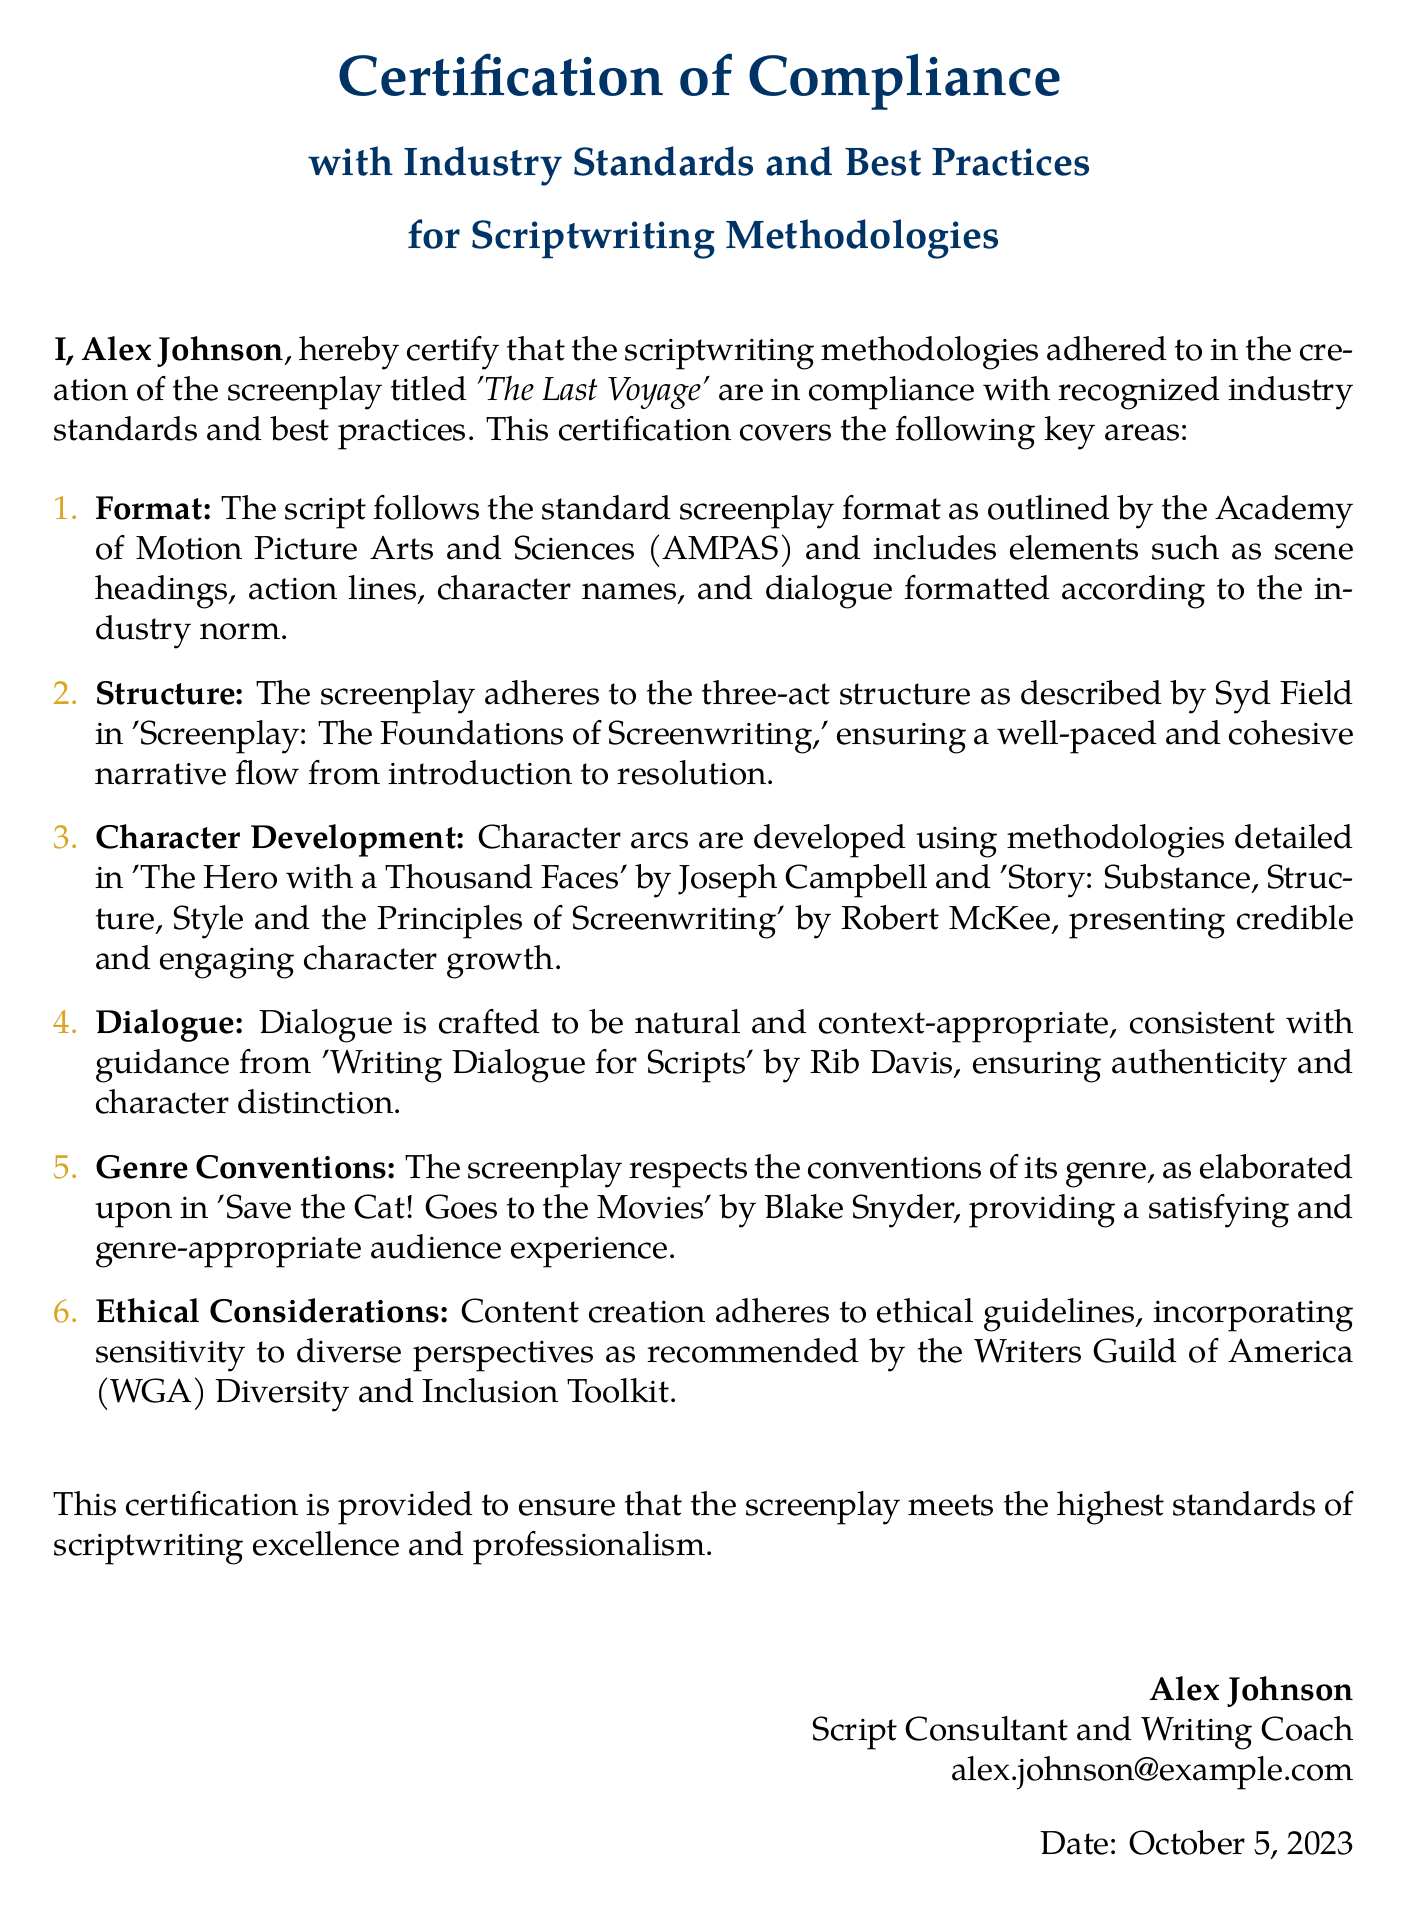What is the name of the author of the declaration? The declaration is signed by Alex Johnson, who is the author.
Answer: Alex Johnson What is the title of the screenplay mentioned in the declaration? The title of the screenplay is explicitly stated as 'The Last Voyage.'
Answer: 'The Last Voyage' What is the date of the declaration? The document specifies the date when it was signed as October 5, 2023.
Answer: October 5, 2023 Which industry standards does this certification claim to comply with? The certification states that it complies with recognized industry standards and best practices in scriptwriting.
Answer: recognized industry standards and best practices What are the six key areas covered in the compliance certification? The document outlines six areas: format, structure, character development, dialogue, genre conventions, and ethical considerations.
Answer: format, structure, character development, dialogue, genre conventions, ethical considerations Who is the organization associated with the Diversity and Inclusion Toolkit mentioned in the declaration? The toolkit mentioned is associated with the Writers Guild of America.
Answer: Writers Guild of America What storytelling structure does the screenplay adhere to? The screenplay follows the three-act structure as described by Syd Field.
Answer: three-act structure What publication is referenced for crafting dialogue? The declaration references 'Writing Dialogue for Scripts' by Rib Davis for guidance on crafting dialogue.
Answer: 'Writing Dialogue for Scripts' by Rib Davis Which publication is cited for genre conventions? The document cites 'Save the Cat! Goes to the Movies' by Blake Snyder regarding genre conventions.
Answer: 'Save the Cat! Goes to the Movies' by Blake Snyder 